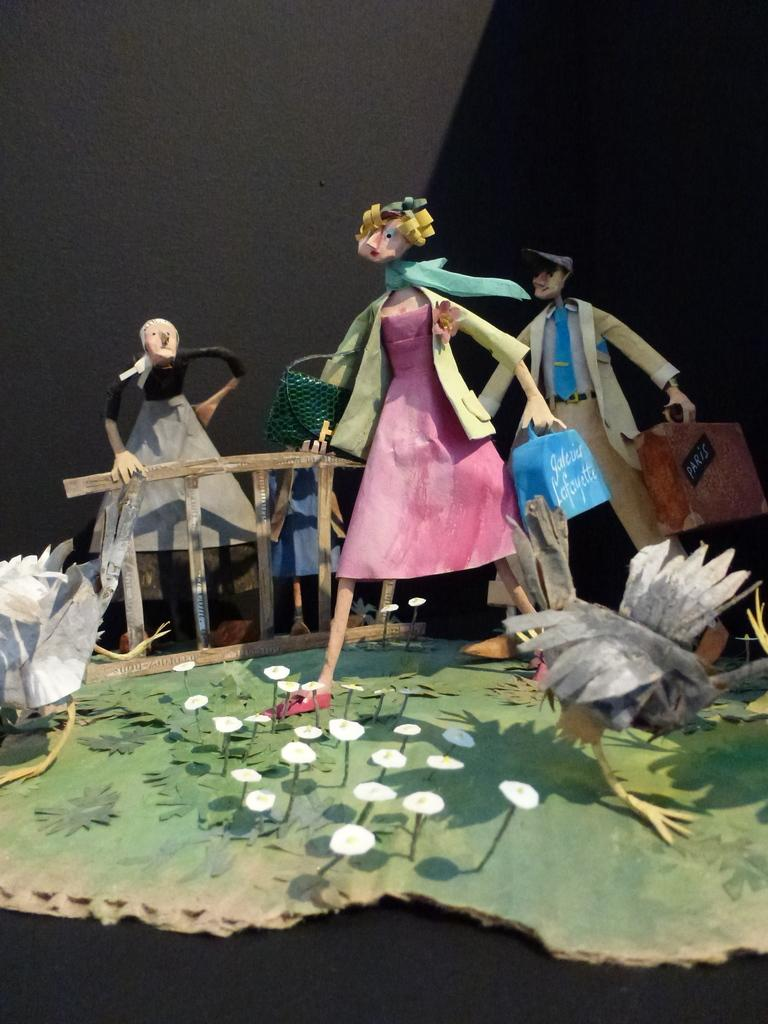What is the main subject in the foreground of the image? There is a craft made of cardboard in the foreground of the image. What can be seen in the background of the image? There is a wall in the background of the image. What type of pot is visible in the image? There is no pot present in the image. Is there any smoke coming from the craft in the image? There is no smoke visible in the image. 